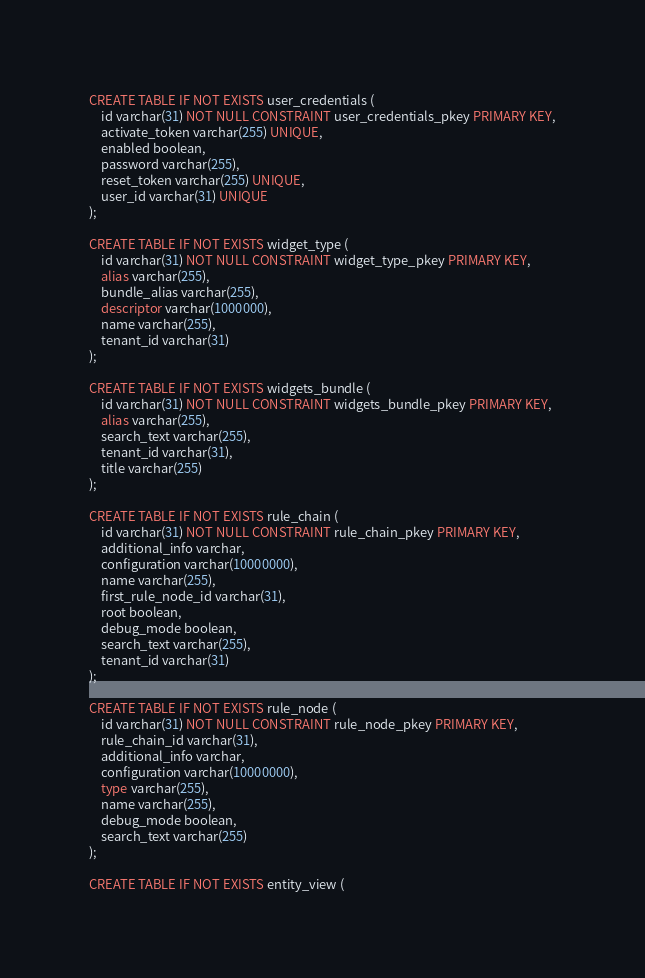<code> <loc_0><loc_0><loc_500><loc_500><_SQL_>
CREATE TABLE IF NOT EXISTS user_credentials (
    id varchar(31) NOT NULL CONSTRAINT user_credentials_pkey PRIMARY KEY,
    activate_token varchar(255) UNIQUE,
    enabled boolean,
    password varchar(255),
    reset_token varchar(255) UNIQUE,
    user_id varchar(31) UNIQUE
);

CREATE TABLE IF NOT EXISTS widget_type (
    id varchar(31) NOT NULL CONSTRAINT widget_type_pkey PRIMARY KEY,
    alias varchar(255),
    bundle_alias varchar(255),
    descriptor varchar(1000000),
    name varchar(255),
    tenant_id varchar(31)
);

CREATE TABLE IF NOT EXISTS widgets_bundle (
    id varchar(31) NOT NULL CONSTRAINT widgets_bundle_pkey PRIMARY KEY,
    alias varchar(255),
    search_text varchar(255),
    tenant_id varchar(31),
    title varchar(255)
);

CREATE TABLE IF NOT EXISTS rule_chain (
    id varchar(31) NOT NULL CONSTRAINT rule_chain_pkey PRIMARY KEY,
    additional_info varchar,
    configuration varchar(10000000),
    name varchar(255),
    first_rule_node_id varchar(31),
    root boolean,
    debug_mode boolean,
    search_text varchar(255),
    tenant_id varchar(31)
);

CREATE TABLE IF NOT EXISTS rule_node (
    id varchar(31) NOT NULL CONSTRAINT rule_node_pkey PRIMARY KEY,
    rule_chain_id varchar(31),
    additional_info varchar,
    configuration varchar(10000000),
    type varchar(255),
    name varchar(255),
    debug_mode boolean,
    search_text varchar(255)
);

CREATE TABLE IF NOT EXISTS entity_view (</code> 